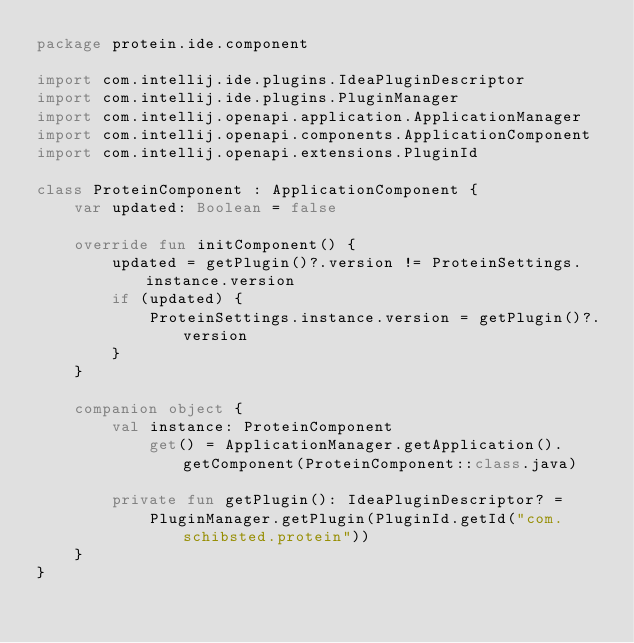<code> <loc_0><loc_0><loc_500><loc_500><_Kotlin_>package protein.ide.component

import com.intellij.ide.plugins.IdeaPluginDescriptor
import com.intellij.ide.plugins.PluginManager
import com.intellij.openapi.application.ApplicationManager
import com.intellij.openapi.components.ApplicationComponent
import com.intellij.openapi.extensions.PluginId

class ProteinComponent : ApplicationComponent {
    var updated: Boolean = false

    override fun initComponent() {
        updated = getPlugin()?.version != ProteinSettings.instance.version
        if (updated) {
            ProteinSettings.instance.version = getPlugin()?.version
        }
    }

    companion object {
        val instance: ProteinComponent
            get() = ApplicationManager.getApplication().getComponent(ProteinComponent::class.java)

        private fun getPlugin(): IdeaPluginDescriptor? =
            PluginManager.getPlugin(PluginId.getId("com.schibsted.protein"))
    }
}
</code> 